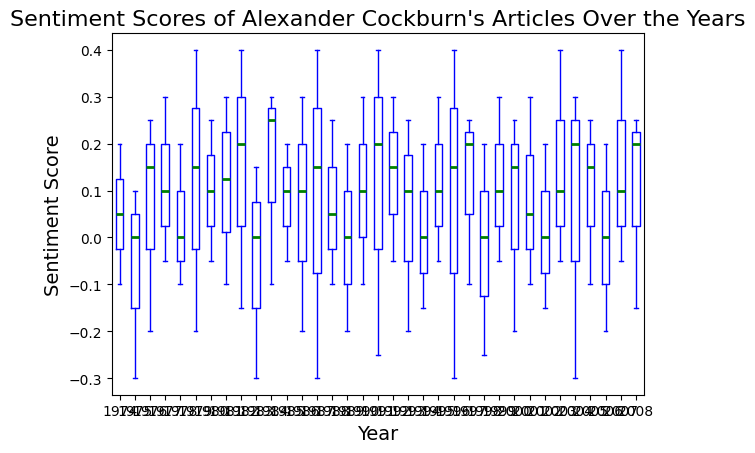What is the median sentiment score in the year 1982? To find the median sentiment score for 1982, identify the middle value in the sorted list of scores for that year. The sentiment scores for 1982 are 0.4, 0.2, and -0.15. The median is 0.2.
Answer: 0.2 Which year has the highest median sentiment score? Examine the median line of the boxplots for each year and find the highest median. The year with the highest median sentiment score is 1991.
Answer: 1991 Are there any years with outlier sentiment scores, and if so, which years? Look for points that fall outside the whiskers of the boxplots. These points are considered outliers. The years with outliers are 1975, 1983, 1987, 1988, 1992, 1996, 1998, 2004.
Answer: 1975, 1983, 1987, 1988, 1992, 1996, 1998, 2004 Which year has the greatest range of sentiment scores? Determine the range by subtracting the minimum score (bottom whisker) from the maximum score (top whisker) for each year's boxplot. The year with the greatest range of sentiment scores is 2004.
Answer: 2004 Is there a general trend in the sentiment scores over the years? Observe the overall changes in the position of the boxplots' medians and ranges from 1974 to 2008. Generally, the sentiment scores seem to become more positive in later years, especially from the mid-1990s onward.
Answer: Sentiment scores become more positive over the years In which year(s) do the median sentiment scores equal zero? Identify the years where the median line of the boxplot intersects the zero line on the y-axis. The median sentiment scores are zero in 1975, 1978, 1983, 1989, 1994, 1998, 2002, and 2006.
Answer: 1975, 1978, 1983, 1989, 1994, 1998, 2002, 2006 How does the median sentiment score in 1985 compare to that in 1995? Compare the position of the median line in the 1985 boxplot to the median line in the 1995 boxplot. The median sentiment score in 1985 is higher than in 1995.
Answer: 1985 is higher What is the interquartile range (IQR) of the sentiment scores in 1990? The IQR is the difference between the first quartile (Q1) and the third quartile (Q3), represented by the bottom and top edges of the box. In 1990, Q1 is 0.1, and Q3 is 0.3, so the IQR is 0.3 - 0.1 = 0.2.
Answer: 0.2 Which year has the lowest minimum sentiment score? Look for the lowest point along the y-axis on the lower whiskers of the boxplots. The year with the lowest minimum sentiment score is 1992, with a score of -0.25.
Answer: 1992 